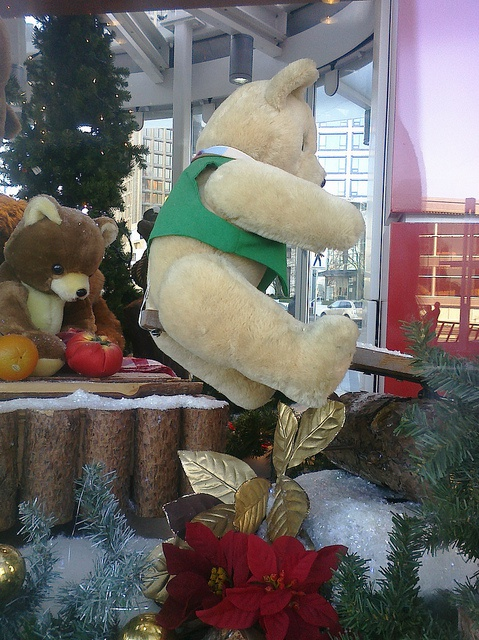Describe the objects in this image and their specific colors. I can see teddy bear in gray and tan tones, teddy bear in gray, maroon, and black tones, and car in gray, lightgray, and darkgray tones in this image. 